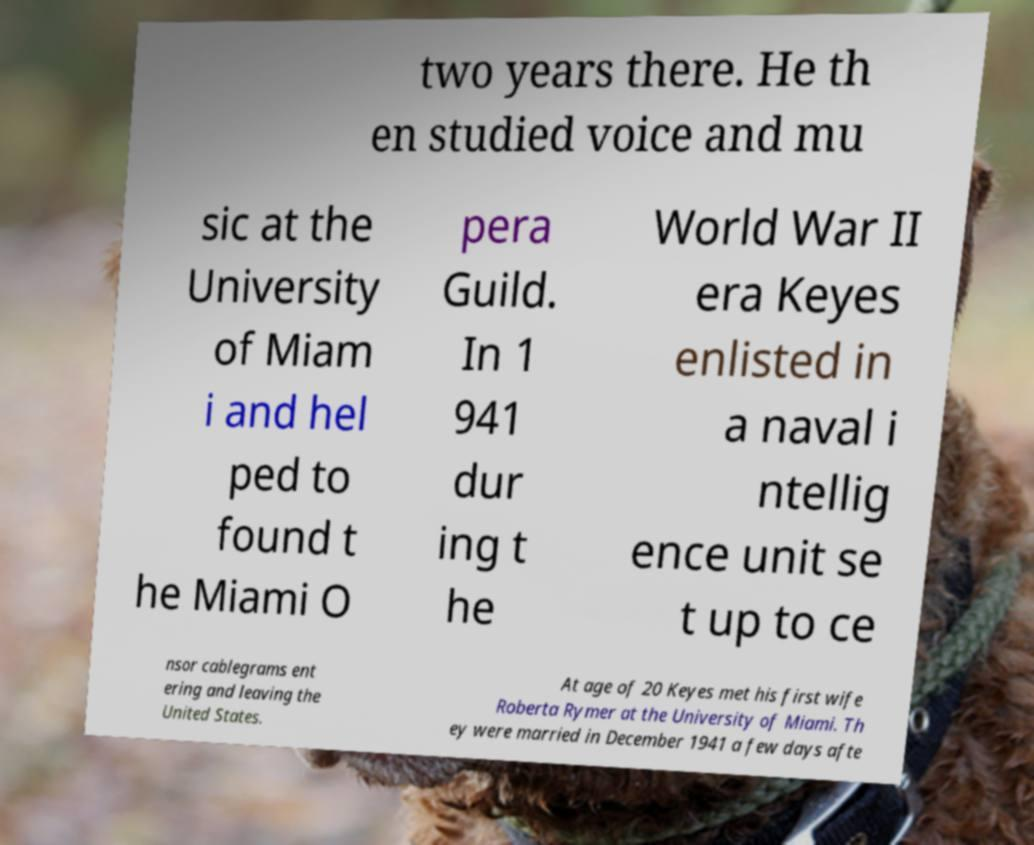Could you extract and type out the text from this image? two years there. He th en studied voice and mu sic at the University of Miam i and hel ped to found t he Miami O pera Guild. In 1 941 dur ing t he World War II era Keyes enlisted in a naval i ntellig ence unit se t up to ce nsor cablegrams ent ering and leaving the United States. At age of 20 Keyes met his first wife Roberta Rymer at the University of Miami. Th ey were married in December 1941 a few days afte 